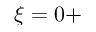<formula> <loc_0><loc_0><loc_500><loc_500>\xi = 0 +</formula> 